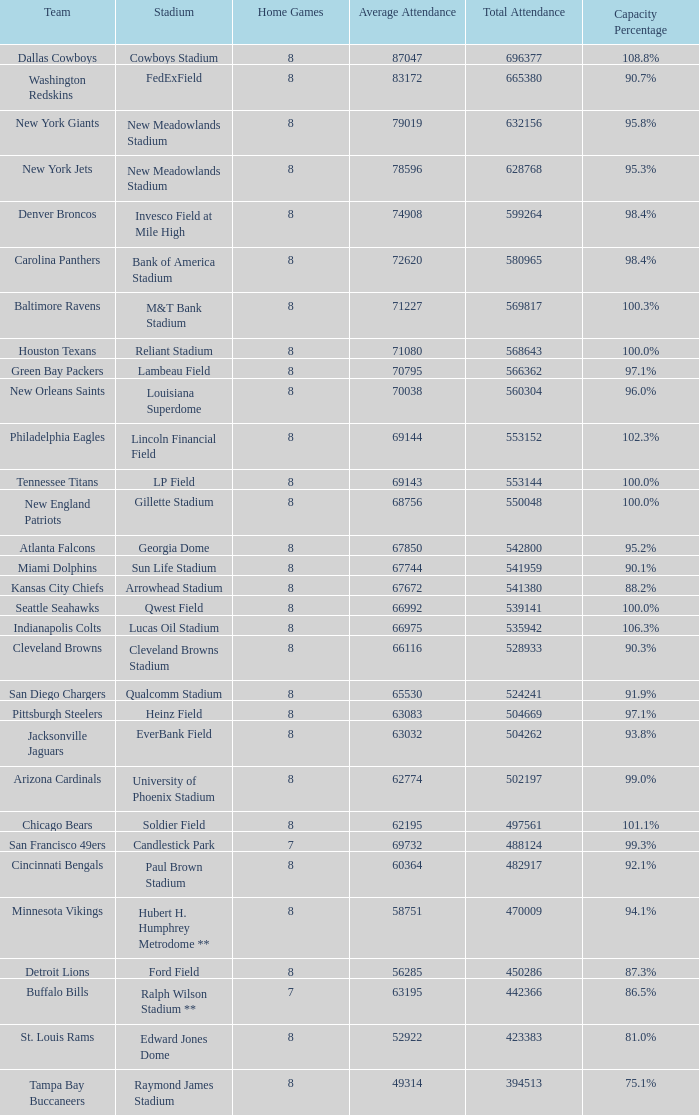What was the total attendance of the New York Giants? 632156.0. 